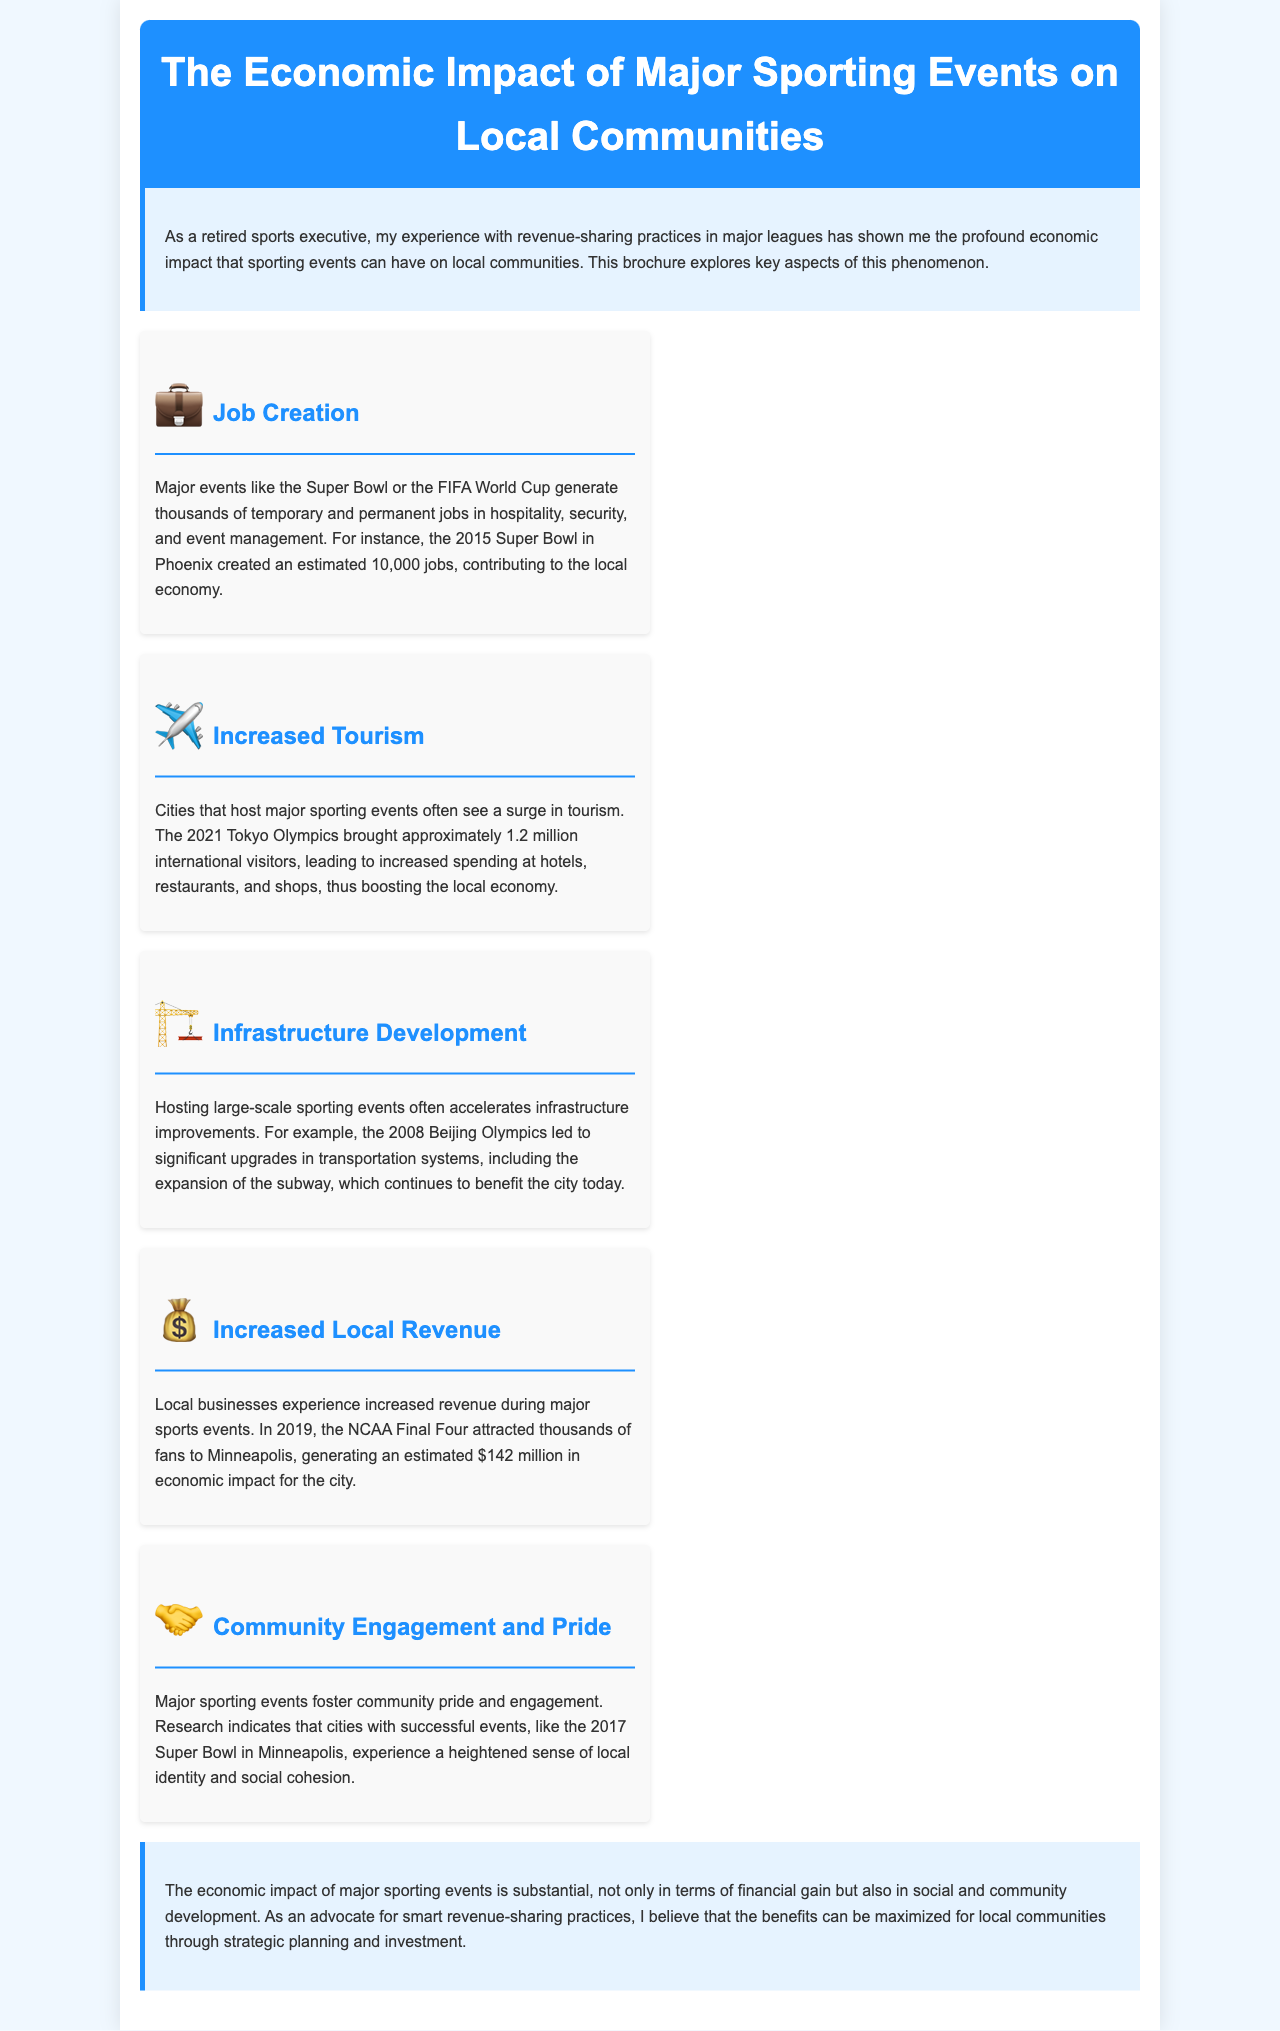what is the title of the brochure? The title is prominently displayed at the top of the document and is "The Economic Impact of Major Sporting Events on Local Communities."
Answer: The Economic Impact of Major Sporting Events on Local Communities how many jobs were created by the 2015 Super Bowl? The document states that the 2015 Super Bowl created an estimated 10,000 jobs.
Answer: 10,000 what event brought approximately 1.2 million international visitors? The text mentions that the 2021 Tokyo Olympics brought approximately 1.2 million international visitors.
Answer: 2021 Tokyo Olympics which city experienced a significant economic impact of $142 million in 2019? The NCAA Final Four in Minneapolis generated an estimated $142 million in economic impact for the city in 2019.
Answer: Minneapolis what type of development is accelerated by hosting large-scale sporting events? The document specifies that hosting large-scale sporting events often accelerates infrastructure development.
Answer: Infrastructure development how did the 2017 Super Bowl affect local identity? Research indicates that cities with successful events like the 2017 Super Bowl experience a heightened sense of local identity and social cohesion.
Answer: Heightened sense of local identity what is a main benefit of strategic planning and investment mentioned in the conclusion? The conclusion emphasizes that the benefits can be maximized for local communities through strategic planning and investment.
Answer: Maximize benefits what document type does this content represent? The formatting and structure suggest that this is a brochure, designed to present information succinctly.
Answer: Brochure 